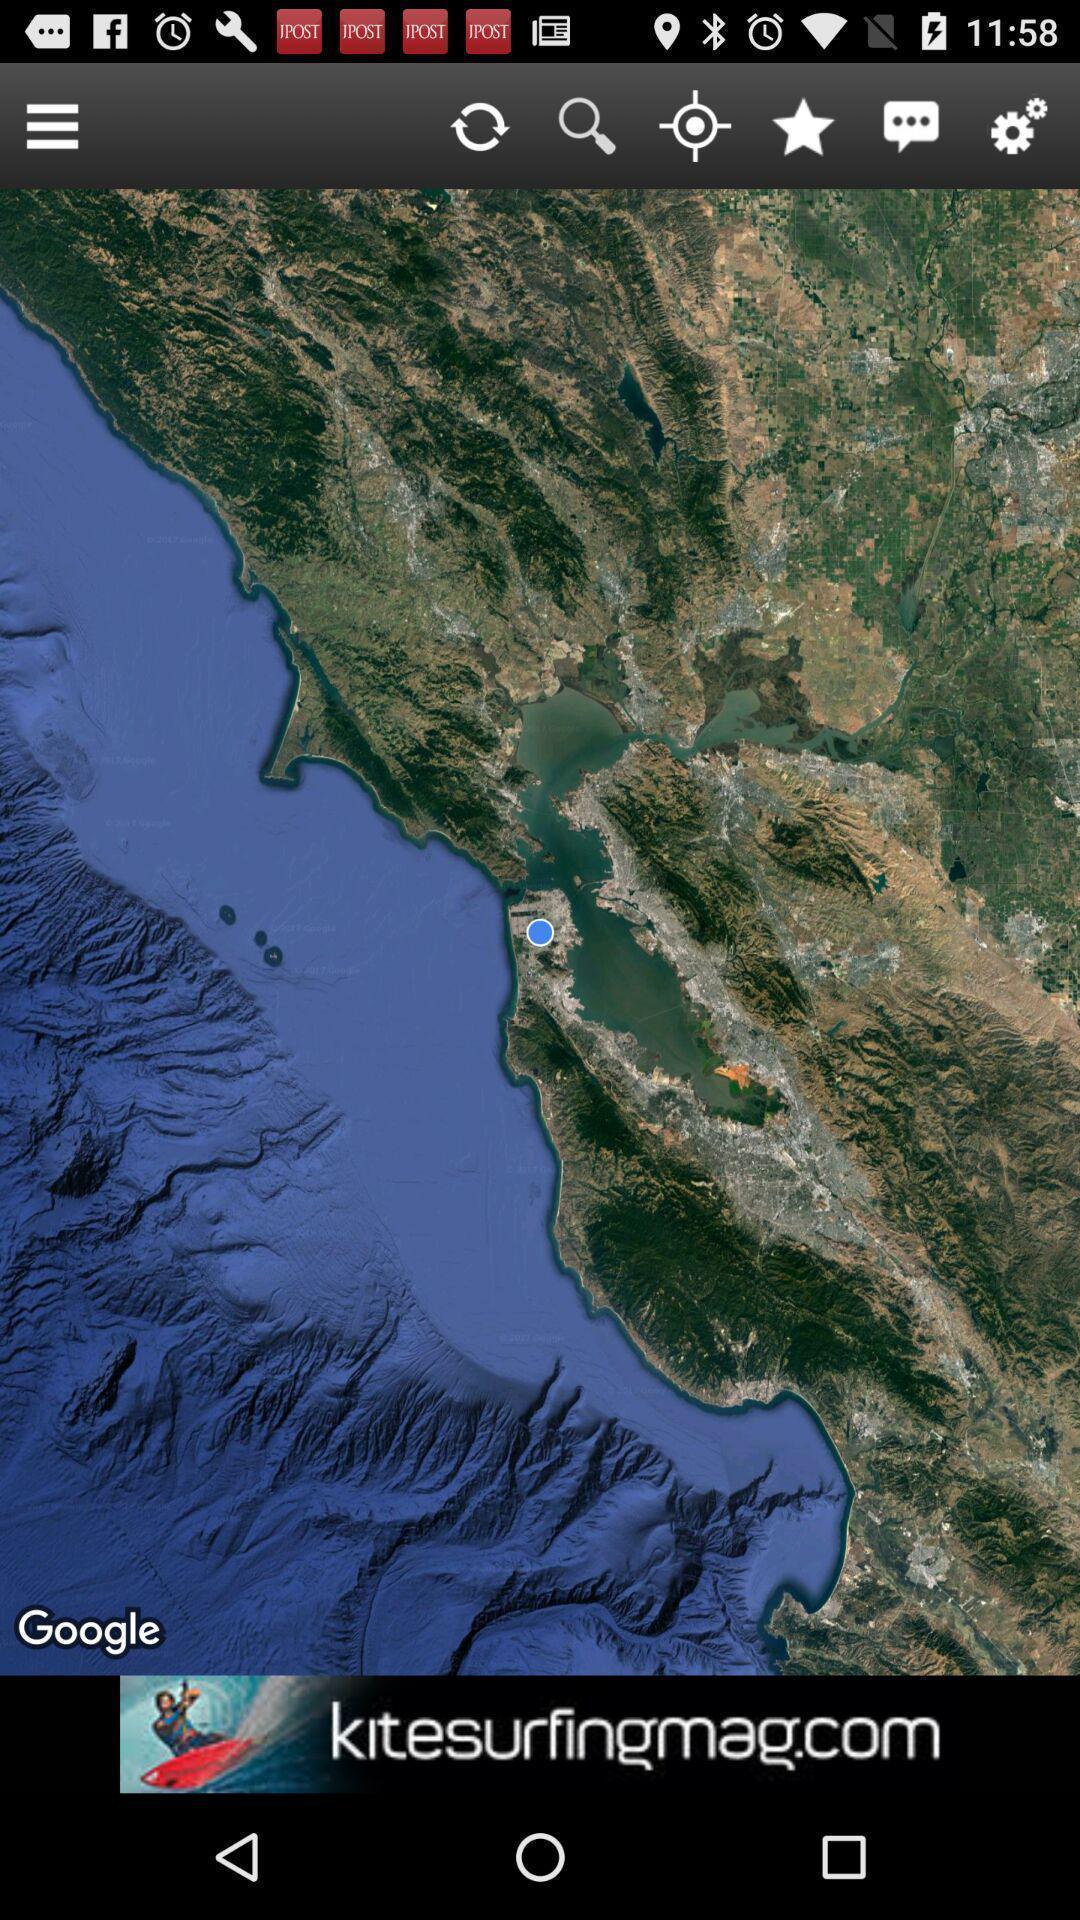Explain the elements present in this screenshot. Screen showing page of an weather application. 